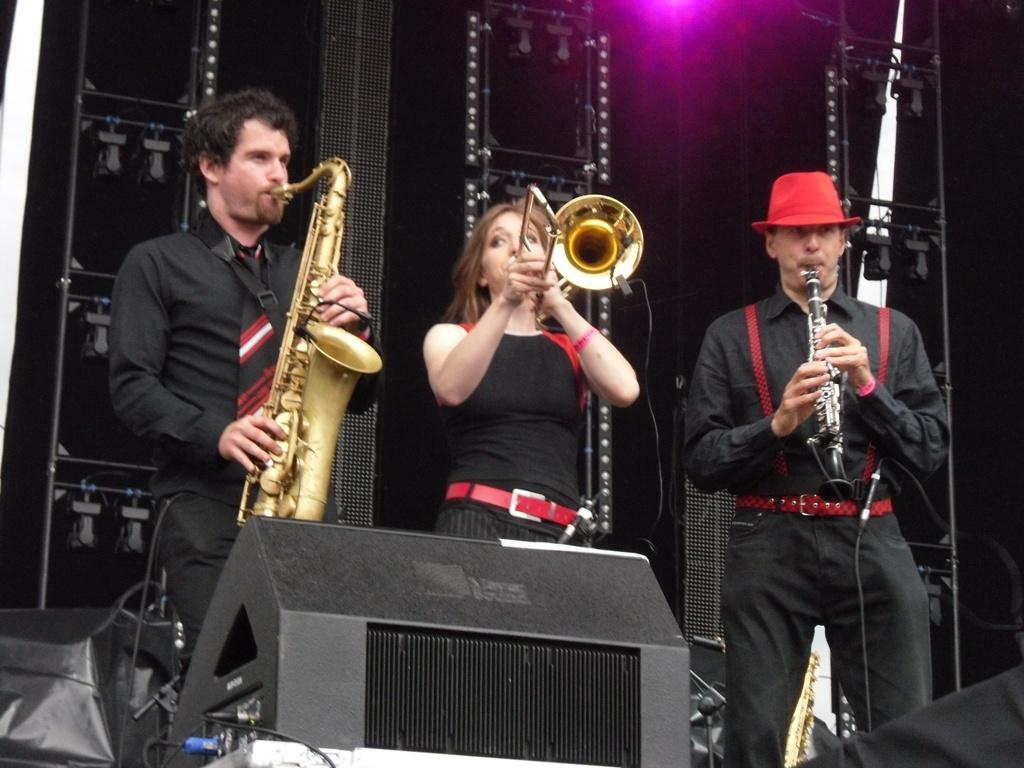How many people are in the image? There are three persons in the image. What are the people wearing? The persons are wearing black color dress. What are the people doing in the image? The persons are playing musical instruments. What color is the cloth in the background of the image? There is a black color cloth in the background of the image. Are there any sticks visible in the image? There are no sticks visible in the image. What type of house can be seen in the background of the image? There is no house present in the image; it only features three persons playing musical instruments and a black color cloth in the background. 